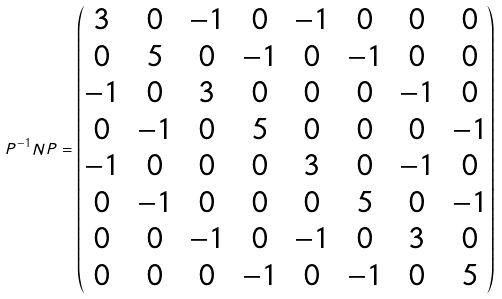Convert formula to latex. <formula><loc_0><loc_0><loc_500><loc_500>P ^ { - 1 } N P = \begin{pmatrix} 3 & 0 & - 1 & 0 & - 1 & 0 & 0 & 0 \\ 0 & 5 & 0 & - 1 & 0 & - 1 & 0 & 0 \\ - 1 & 0 & 3 & 0 & 0 & 0 & - 1 & 0 \\ 0 & - 1 & 0 & 5 & 0 & 0 & 0 & - 1 \\ - 1 & 0 & 0 & 0 & 3 & 0 & - 1 & 0 \\ 0 & - 1 & 0 & 0 & 0 & 5 & 0 & - 1 \\ 0 & 0 & - 1 & 0 & - 1 & 0 & 3 & 0 \\ 0 & 0 & 0 & - 1 & 0 & - 1 & 0 & 5 \end{pmatrix}</formula> 